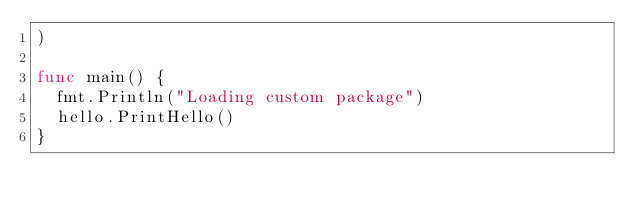Convert code to text. <code><loc_0><loc_0><loc_500><loc_500><_Go_>)

func main() {
  fmt.Println("Loading custom package")
  hello.PrintHello()
}
</code> 